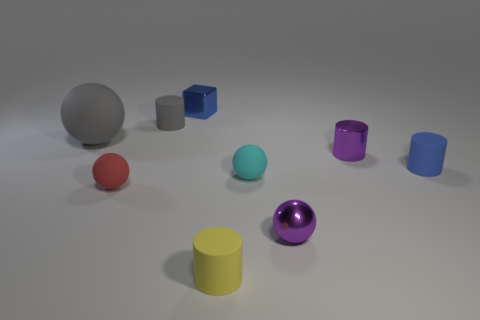Is there a tiny matte cylinder that has the same color as the big object?
Provide a succinct answer. Yes. Is the tiny shiny ball the same color as the metallic cylinder?
Make the answer very short. Yes. What number of things are to the left of the metallic block and behind the large rubber thing?
Your answer should be very brief. 1. What is the shape of the tiny cyan matte object?
Give a very brief answer. Sphere. What number of other things are there of the same material as the small yellow cylinder
Keep it short and to the point. 5. What is the color of the tiny matte object behind the small blue object in front of the blue object that is on the left side of the purple shiny ball?
Give a very brief answer. Gray. What is the material of the cyan object that is the same size as the purple cylinder?
Offer a terse response. Rubber. What number of objects are either tiny matte objects that are behind the purple shiny cylinder or small yellow rubber things?
Offer a terse response. 2. Are there any large red things?
Your answer should be compact. No. There is a purple thing behind the blue matte object; what is it made of?
Offer a terse response. Metal. 